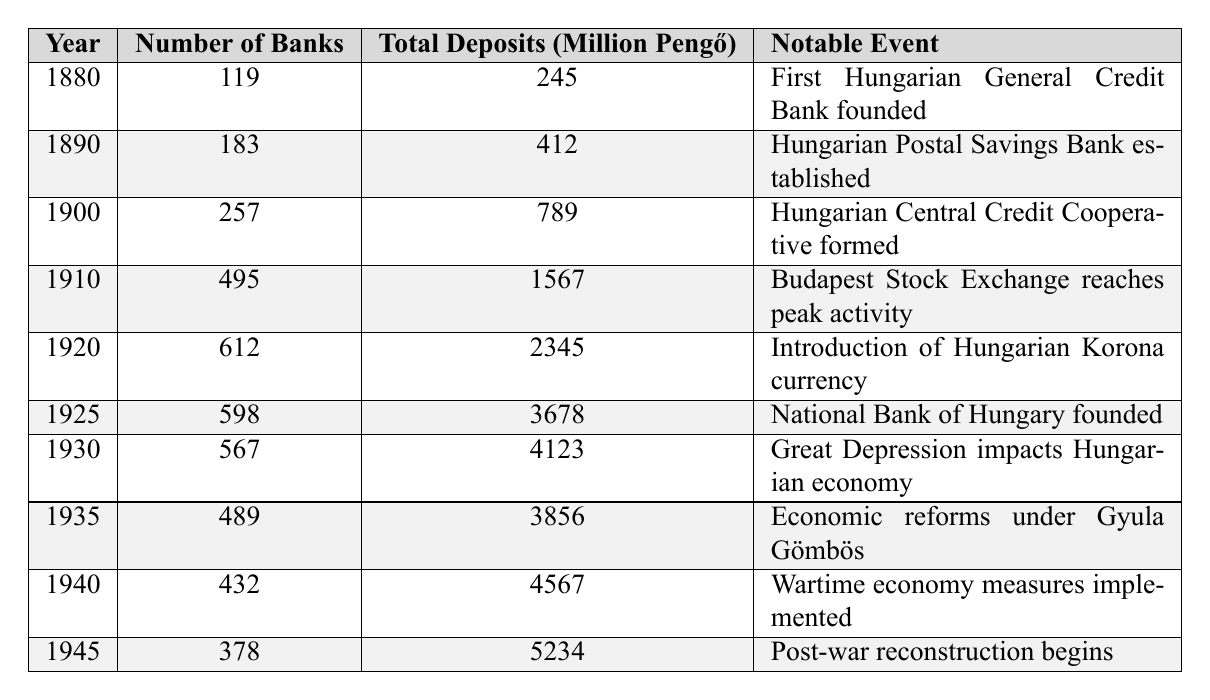What year had the highest number of banks? The highest number of banks is found in the year 1910, with 495 banks listed in that year.
Answer: 1910 What was the total amount of deposits in 1925? The total deposits in 1925 are stated as 3678 million Pengő.
Answer: 3678 million Pengő By how much did the number of banks decrease from 1920 to 1930? In 1920, there were 612 banks, which decreased to 567 by 1930. The difference is 612 - 567 = 45 banks.
Answer: 45 banks Was there an increase in total deposits from 1930 to 1940? In 1930 the total deposits were 4123 million Pengő, while in 1940 they rose to 4567 million Pengő, indicating an increase.
Answer: Yes What is the average number of banks from 1880 to 1945? To find the average, sum the total number of banks (119 + 183 + 257 + 495 + 612 + 598 + 567 + 489 + 432 + 378 = 3920) and divide by the number of years (10). Thus, the average is 3920 / 10 = 392.
Answer: 392 Which decade saw the largest increase in total deposits? The decade from 1920 to 1930 experienced the largest increase, with deposits rising from 2345 to 4123 million Pengő, an increase of 1778 million Pengő.
Answer: 1920 to 1930 What notable event occurred in the year 1945? In 1945, the notable event listed is the beginning of post-war reconstruction.
Answer: Post-war reconstruction begins Did the total deposits increase every year from 1880 to 1945? Reviewing the total deposits, there were decreases in certain years. For example, from 1910 to 1920, deposits dropped from 1567 to 2345 million Pengő, confirming there were fluctuations.
Answer: No How many total deposits were there in 1940? The table indicates that in 1940, total deposits amounted to 4567 million Pengő.
Answer: 4567 million Pengő What trend can be observed in the number of banks from 1880 to 1945? The trend shows an initial increase in the number of banks until 1910, followed by fluctuations with a general decline later towards 1945.
Answer: Fluctuations with a general decline 